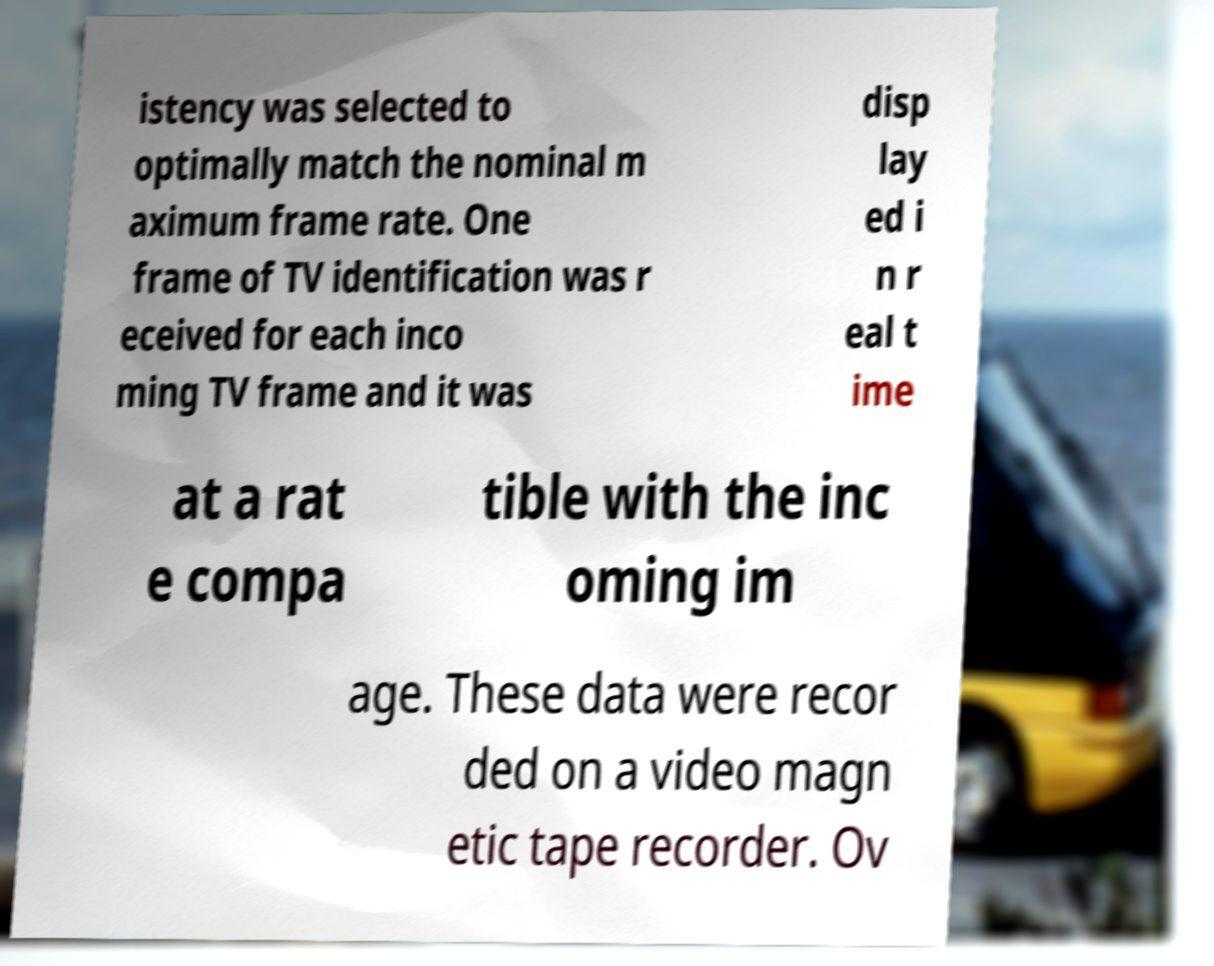I need the written content from this picture converted into text. Can you do that? istency was selected to optimally match the nominal m aximum frame rate. One frame of TV identification was r eceived for each inco ming TV frame and it was disp lay ed i n r eal t ime at a rat e compa tible with the inc oming im age. These data were recor ded on a video magn etic tape recorder. Ov 